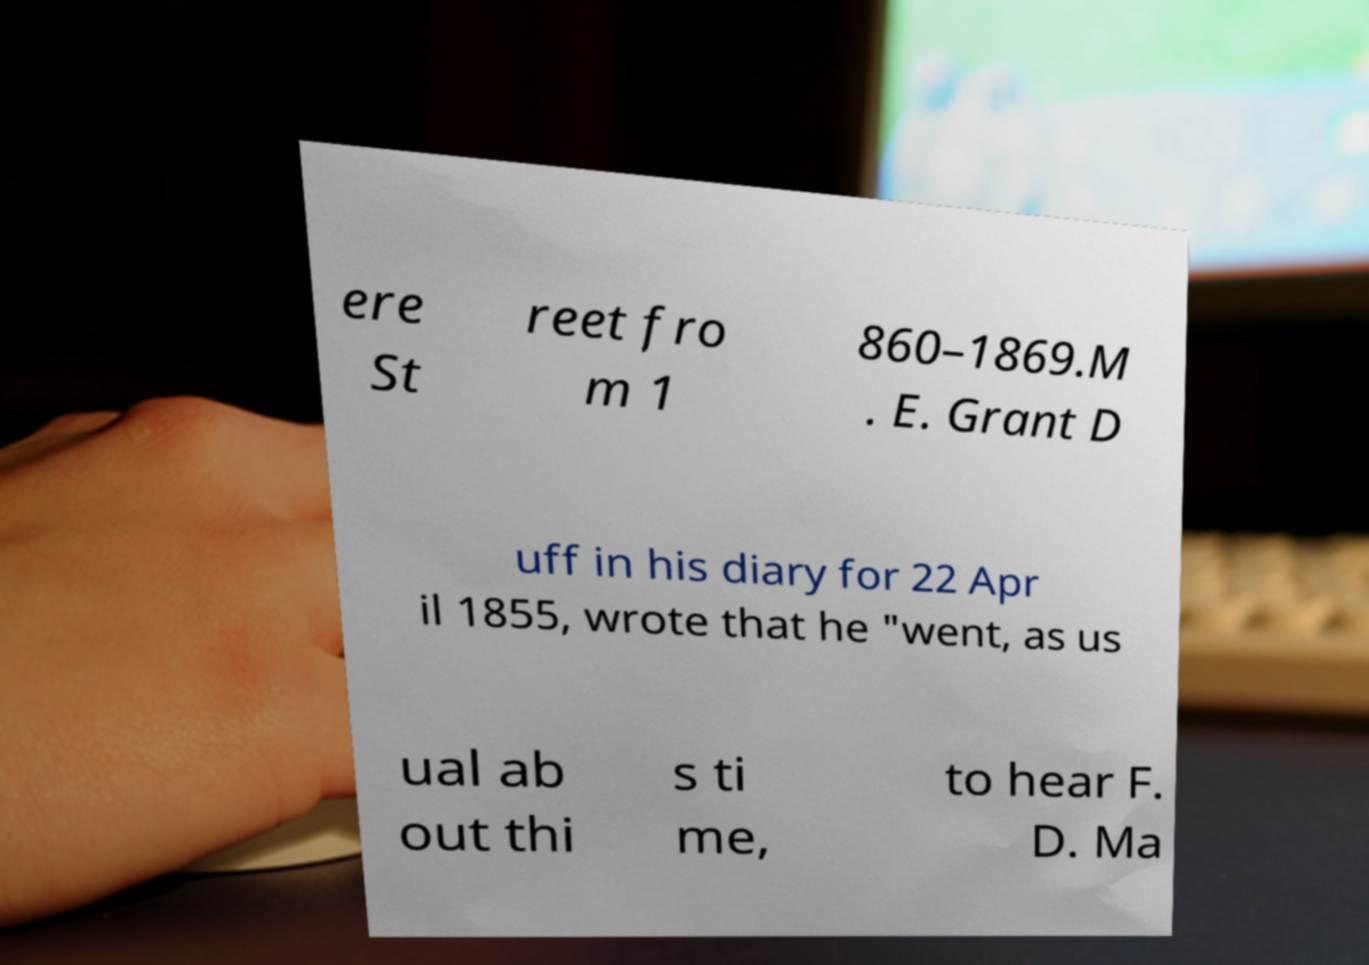Can you accurately transcribe the text from the provided image for me? ere St reet fro m 1 860–1869.M . E. Grant D uff in his diary for 22 Apr il 1855, wrote that he "went, as us ual ab out thi s ti me, to hear F. D. Ma 